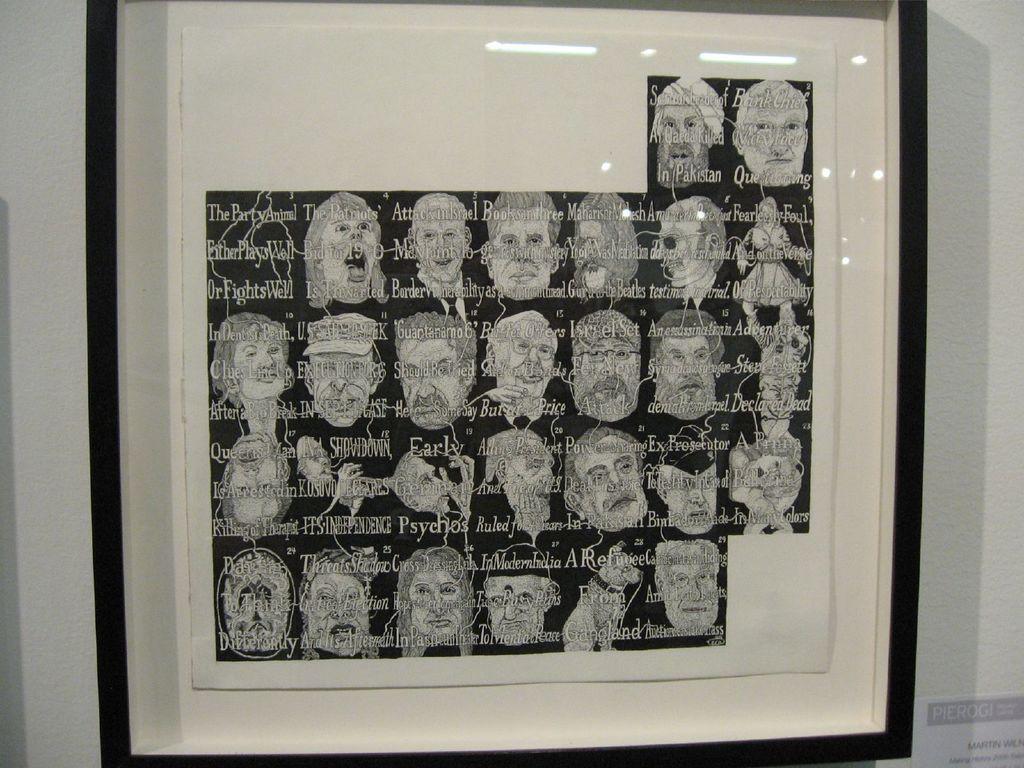Describe this image in one or two sentences. In this image we can see a frame on a wall with some pictures and text on it. At the bottom right we can see a paper on a wall with some text on it. 